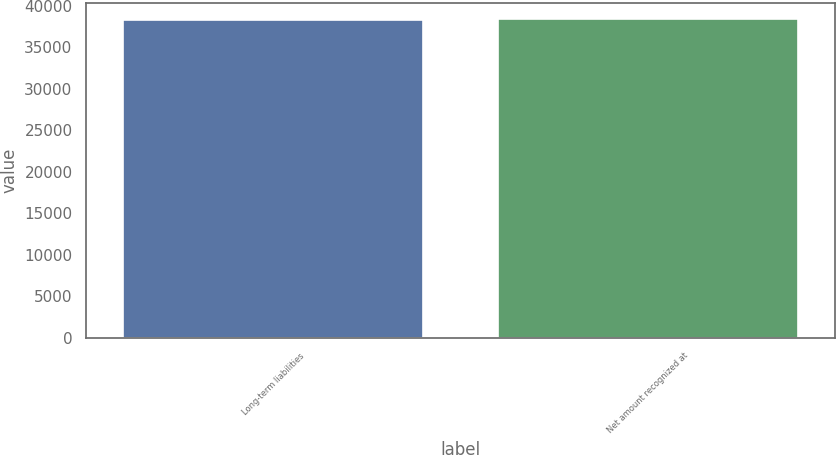<chart> <loc_0><loc_0><loc_500><loc_500><bar_chart><fcel>Long-term liabilities<fcel>Net amount recognized at<nl><fcel>38335<fcel>38475<nl></chart> 